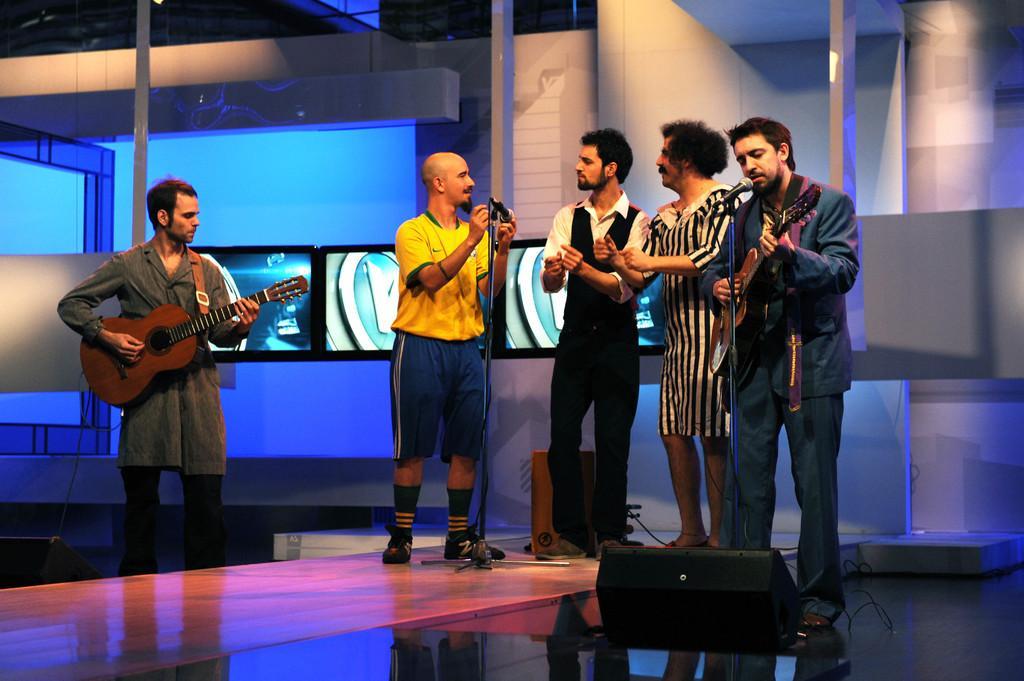Can you describe this image briefly? At the left side of the picture we can see a man standing and playing a guitar. Here in front of a mike there are four persons. One is playing guitar and the three are singing. This is a platform. This is a guitar. 